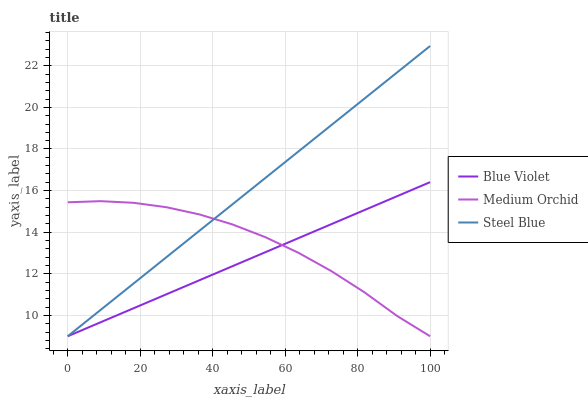Does Blue Violet have the minimum area under the curve?
Answer yes or no. Yes. Does Steel Blue have the maximum area under the curve?
Answer yes or no. Yes. Does Steel Blue have the minimum area under the curve?
Answer yes or no. No. Does Blue Violet have the maximum area under the curve?
Answer yes or no. No. Is Steel Blue the smoothest?
Answer yes or no. Yes. Is Medium Orchid the roughest?
Answer yes or no. Yes. Is Blue Violet the smoothest?
Answer yes or no. No. Is Blue Violet the roughest?
Answer yes or no. No. Does Medium Orchid have the lowest value?
Answer yes or no. Yes. Does Steel Blue have the highest value?
Answer yes or no. Yes. Does Blue Violet have the highest value?
Answer yes or no. No. Does Steel Blue intersect Blue Violet?
Answer yes or no. Yes. Is Steel Blue less than Blue Violet?
Answer yes or no. No. Is Steel Blue greater than Blue Violet?
Answer yes or no. No. 